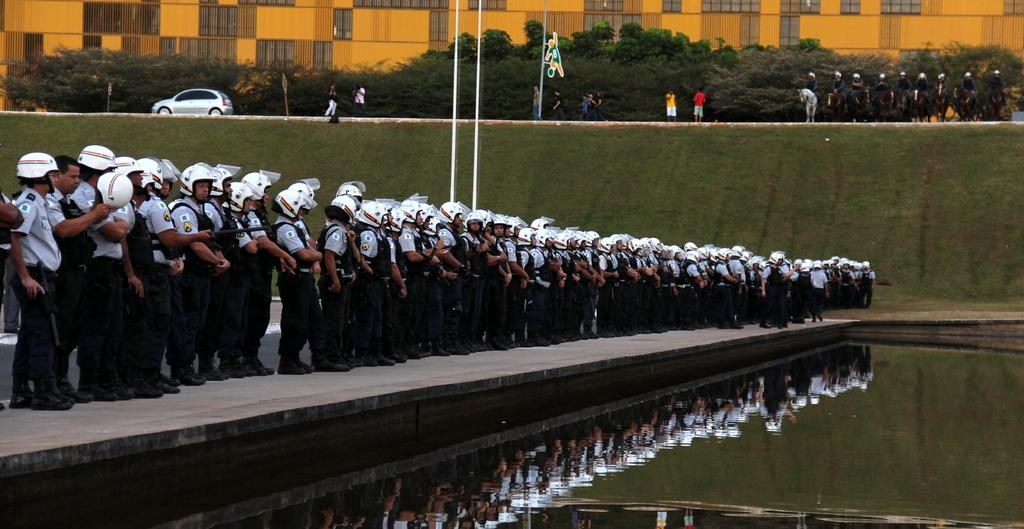How many people are in the image? There is a group of people in the image. What are the people wearing on their heads? The people are wearing helmets. Where are the people standing? The people are standing on a platform. What can be seen in the image besides the people? There are poles, trees, horses, a car, and a building with windows in the background of the image. What type of locket is hanging from the pole in the image? There is no locket present in the image; there are only poles and other objects mentioned in the facts. 